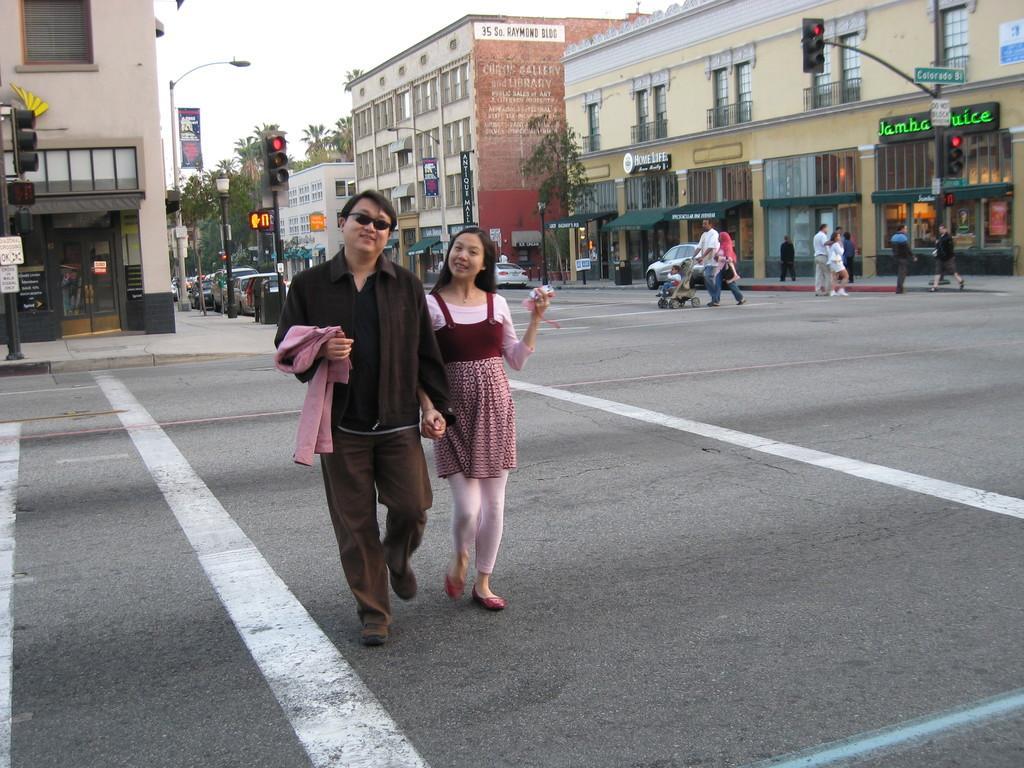How would you summarize this image in a sentence or two? In the center of the image there are two people walking on the road. In the background of the image there are buildings,trees. There is a traffic signal. There are vehicles on the road. There are people crossing the road. At the top of the image there is sky. 